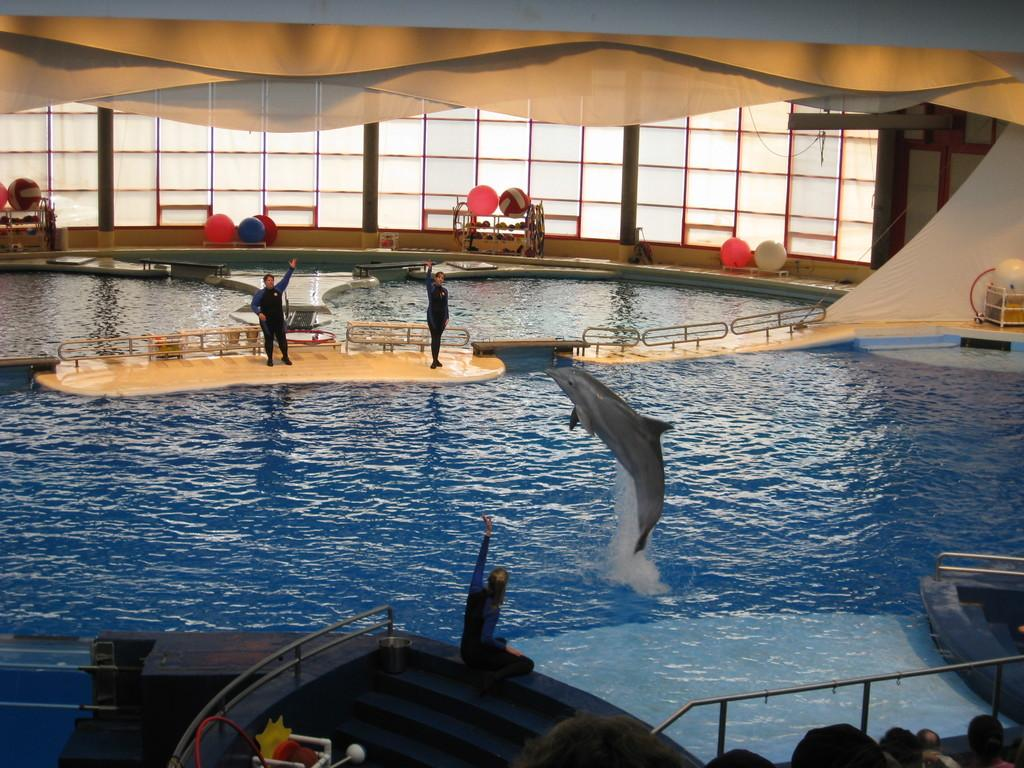What is visible in the image? There is water, three people, a dolphin, and balls in the background. Can you describe the people in the image? There are three people in the image. What is the dolphin doing in the image? The dolphin is in the water. What can be seen in the background of the image? There are windows and balls in the background. How many beams are supporting the structure in the image? There is no structure or beam present in the image. What type of parenting advice can be seen in the image? There is no parenting advice or parent in the image. 